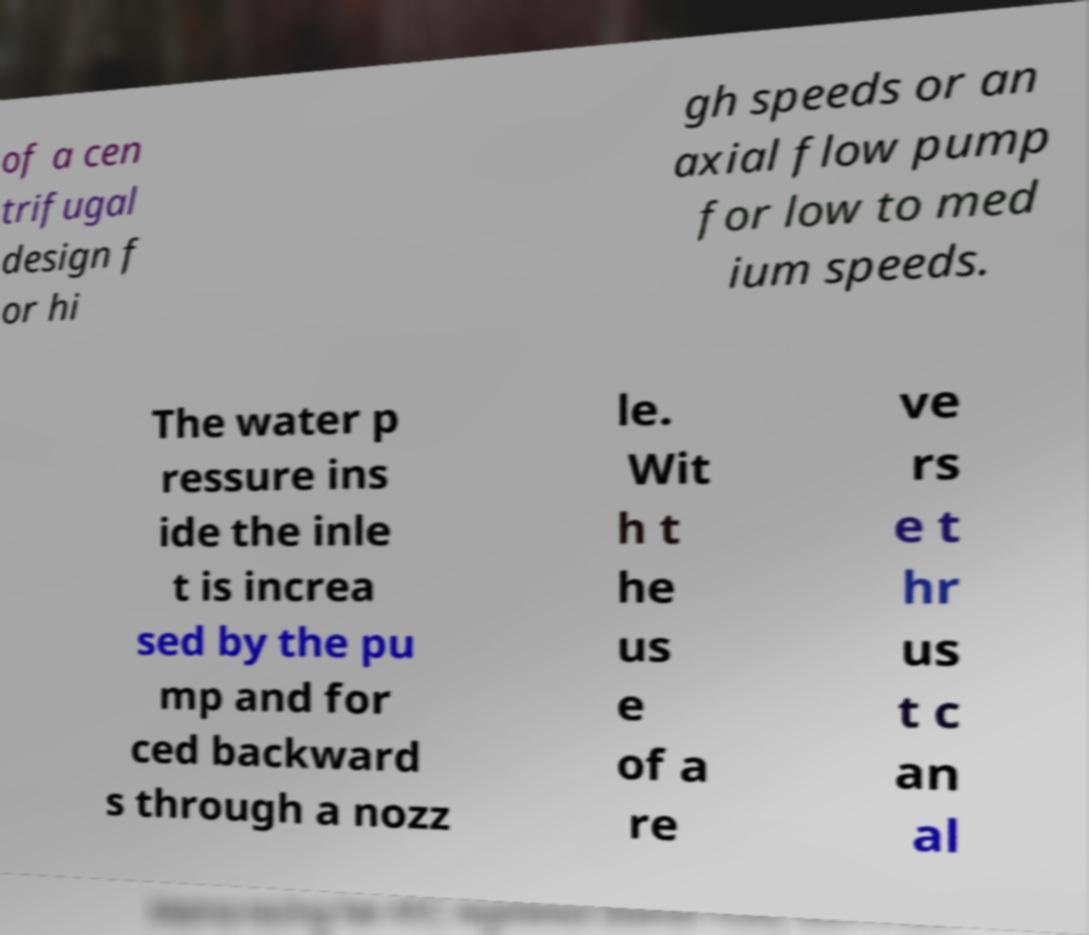Can you accurately transcribe the text from the provided image for me? of a cen trifugal design f or hi gh speeds or an axial flow pump for low to med ium speeds. The water p ressure ins ide the inle t is increa sed by the pu mp and for ced backward s through a nozz le. Wit h t he us e of a re ve rs e t hr us t c an al 